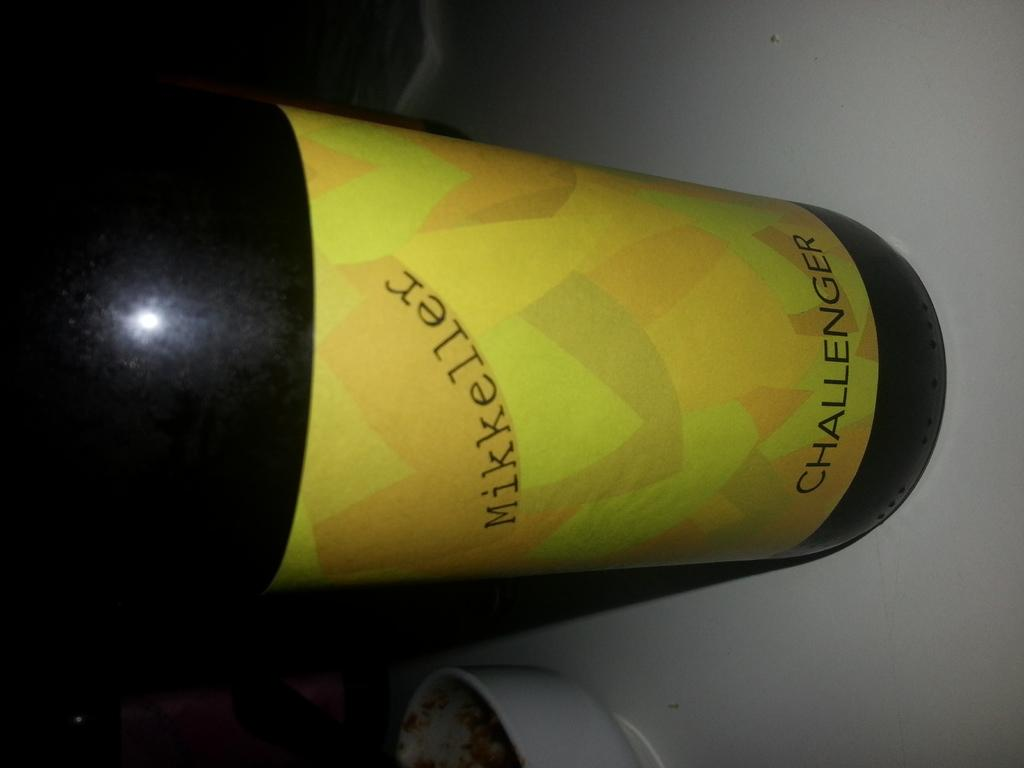<image>
Share a concise interpretation of the image provided. A bottle of Mikkeller Challenger on a table. 